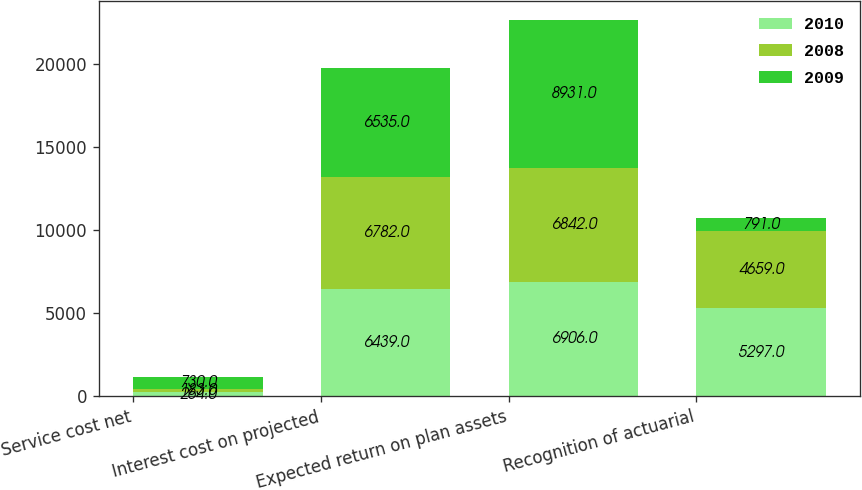<chart> <loc_0><loc_0><loc_500><loc_500><stacked_bar_chart><ecel><fcel>Service cost net<fcel>Interest cost on projected<fcel>Expected return on plan assets<fcel>Recognition of actuarial<nl><fcel>2010<fcel>264<fcel>6439<fcel>6906<fcel>5297<nl><fcel>2008<fcel>183<fcel>6782<fcel>6842<fcel>4659<nl><fcel>2009<fcel>730<fcel>6535<fcel>8931<fcel>791<nl></chart> 